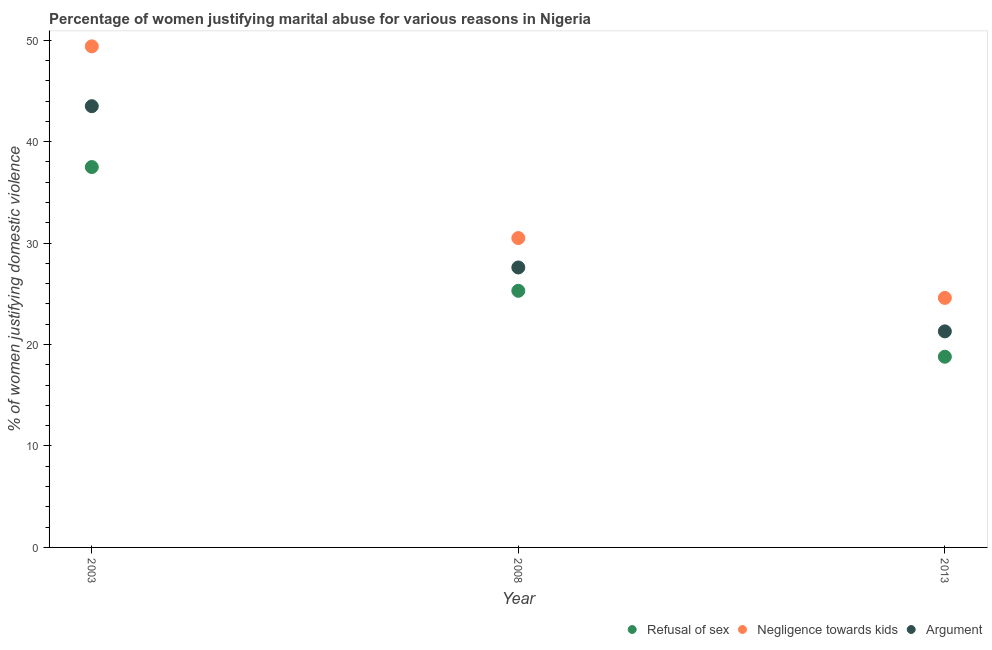What is the percentage of women justifying domestic violence due to negligence towards kids in 2008?
Your response must be concise. 30.5. Across all years, what is the maximum percentage of women justifying domestic violence due to arguments?
Provide a short and direct response. 43.5. In which year was the percentage of women justifying domestic violence due to negligence towards kids maximum?
Make the answer very short. 2003. What is the total percentage of women justifying domestic violence due to arguments in the graph?
Ensure brevity in your answer.  92.4. What is the difference between the percentage of women justifying domestic violence due to refusal of sex in 2008 and that in 2013?
Give a very brief answer. 6.5. What is the average percentage of women justifying domestic violence due to refusal of sex per year?
Provide a short and direct response. 27.2. In the year 2013, what is the difference between the percentage of women justifying domestic violence due to refusal of sex and percentage of women justifying domestic violence due to negligence towards kids?
Offer a very short reply. -5.8. What is the ratio of the percentage of women justifying domestic violence due to arguments in 2008 to that in 2013?
Offer a terse response. 1.3. What is the difference between the highest and the second highest percentage of women justifying domestic violence due to arguments?
Provide a short and direct response. 15.9. What is the difference between the highest and the lowest percentage of women justifying domestic violence due to negligence towards kids?
Make the answer very short. 24.8. In how many years, is the percentage of women justifying domestic violence due to negligence towards kids greater than the average percentage of women justifying domestic violence due to negligence towards kids taken over all years?
Make the answer very short. 1. Is it the case that in every year, the sum of the percentage of women justifying domestic violence due to refusal of sex and percentage of women justifying domestic violence due to negligence towards kids is greater than the percentage of women justifying domestic violence due to arguments?
Offer a very short reply. Yes. Does the percentage of women justifying domestic violence due to arguments monotonically increase over the years?
Offer a terse response. No. How many dotlines are there?
Offer a very short reply. 3. What is the difference between two consecutive major ticks on the Y-axis?
Give a very brief answer. 10. Are the values on the major ticks of Y-axis written in scientific E-notation?
Ensure brevity in your answer.  No. Does the graph contain any zero values?
Your response must be concise. No. What is the title of the graph?
Your answer should be very brief. Percentage of women justifying marital abuse for various reasons in Nigeria. Does "Injury" appear as one of the legend labels in the graph?
Make the answer very short. No. What is the label or title of the X-axis?
Your response must be concise. Year. What is the label or title of the Y-axis?
Keep it short and to the point. % of women justifying domestic violence. What is the % of women justifying domestic violence of Refusal of sex in 2003?
Keep it short and to the point. 37.5. What is the % of women justifying domestic violence of Negligence towards kids in 2003?
Provide a short and direct response. 49.4. What is the % of women justifying domestic violence in Argument in 2003?
Make the answer very short. 43.5. What is the % of women justifying domestic violence in Refusal of sex in 2008?
Make the answer very short. 25.3. What is the % of women justifying domestic violence in Negligence towards kids in 2008?
Give a very brief answer. 30.5. What is the % of women justifying domestic violence in Argument in 2008?
Your answer should be compact. 27.6. What is the % of women justifying domestic violence of Refusal of sex in 2013?
Offer a very short reply. 18.8. What is the % of women justifying domestic violence of Negligence towards kids in 2013?
Your answer should be very brief. 24.6. What is the % of women justifying domestic violence of Argument in 2013?
Ensure brevity in your answer.  21.3. Across all years, what is the maximum % of women justifying domestic violence in Refusal of sex?
Keep it short and to the point. 37.5. Across all years, what is the maximum % of women justifying domestic violence in Negligence towards kids?
Provide a short and direct response. 49.4. Across all years, what is the maximum % of women justifying domestic violence in Argument?
Offer a very short reply. 43.5. Across all years, what is the minimum % of women justifying domestic violence in Refusal of sex?
Provide a short and direct response. 18.8. Across all years, what is the minimum % of women justifying domestic violence of Negligence towards kids?
Your response must be concise. 24.6. Across all years, what is the minimum % of women justifying domestic violence of Argument?
Offer a terse response. 21.3. What is the total % of women justifying domestic violence of Refusal of sex in the graph?
Offer a very short reply. 81.6. What is the total % of women justifying domestic violence in Negligence towards kids in the graph?
Your answer should be very brief. 104.5. What is the total % of women justifying domestic violence in Argument in the graph?
Offer a very short reply. 92.4. What is the difference between the % of women justifying domestic violence in Refusal of sex in 2003 and that in 2008?
Provide a short and direct response. 12.2. What is the difference between the % of women justifying domestic violence in Negligence towards kids in 2003 and that in 2008?
Give a very brief answer. 18.9. What is the difference between the % of women justifying domestic violence in Negligence towards kids in 2003 and that in 2013?
Provide a short and direct response. 24.8. What is the difference between the % of women justifying domestic violence in Argument in 2003 and that in 2013?
Provide a succinct answer. 22.2. What is the difference between the % of women justifying domestic violence in Refusal of sex in 2008 and that in 2013?
Offer a terse response. 6.5. What is the difference between the % of women justifying domestic violence in Argument in 2008 and that in 2013?
Your answer should be compact. 6.3. What is the difference between the % of women justifying domestic violence of Negligence towards kids in 2003 and the % of women justifying domestic violence of Argument in 2008?
Your answer should be compact. 21.8. What is the difference between the % of women justifying domestic violence in Refusal of sex in 2003 and the % of women justifying domestic violence in Argument in 2013?
Give a very brief answer. 16.2. What is the difference between the % of women justifying domestic violence of Negligence towards kids in 2003 and the % of women justifying domestic violence of Argument in 2013?
Give a very brief answer. 28.1. What is the difference between the % of women justifying domestic violence of Refusal of sex in 2008 and the % of women justifying domestic violence of Argument in 2013?
Provide a short and direct response. 4. What is the difference between the % of women justifying domestic violence of Negligence towards kids in 2008 and the % of women justifying domestic violence of Argument in 2013?
Offer a very short reply. 9.2. What is the average % of women justifying domestic violence of Refusal of sex per year?
Give a very brief answer. 27.2. What is the average % of women justifying domestic violence of Negligence towards kids per year?
Make the answer very short. 34.83. What is the average % of women justifying domestic violence of Argument per year?
Provide a short and direct response. 30.8. In the year 2003, what is the difference between the % of women justifying domestic violence in Refusal of sex and % of women justifying domestic violence in Negligence towards kids?
Offer a terse response. -11.9. In the year 2003, what is the difference between the % of women justifying domestic violence of Refusal of sex and % of women justifying domestic violence of Argument?
Give a very brief answer. -6. In the year 2003, what is the difference between the % of women justifying domestic violence in Negligence towards kids and % of women justifying domestic violence in Argument?
Your answer should be compact. 5.9. In the year 2008, what is the difference between the % of women justifying domestic violence of Refusal of sex and % of women justifying domestic violence of Argument?
Your answer should be compact. -2.3. In the year 2013, what is the difference between the % of women justifying domestic violence of Refusal of sex and % of women justifying domestic violence of Argument?
Your answer should be compact. -2.5. What is the ratio of the % of women justifying domestic violence in Refusal of sex in 2003 to that in 2008?
Provide a short and direct response. 1.48. What is the ratio of the % of women justifying domestic violence in Negligence towards kids in 2003 to that in 2008?
Give a very brief answer. 1.62. What is the ratio of the % of women justifying domestic violence of Argument in 2003 to that in 2008?
Keep it short and to the point. 1.58. What is the ratio of the % of women justifying domestic violence of Refusal of sex in 2003 to that in 2013?
Your response must be concise. 1.99. What is the ratio of the % of women justifying domestic violence in Negligence towards kids in 2003 to that in 2013?
Your response must be concise. 2.01. What is the ratio of the % of women justifying domestic violence in Argument in 2003 to that in 2013?
Provide a short and direct response. 2.04. What is the ratio of the % of women justifying domestic violence of Refusal of sex in 2008 to that in 2013?
Give a very brief answer. 1.35. What is the ratio of the % of women justifying domestic violence of Negligence towards kids in 2008 to that in 2013?
Ensure brevity in your answer.  1.24. What is the ratio of the % of women justifying domestic violence in Argument in 2008 to that in 2013?
Offer a very short reply. 1.3. What is the difference between the highest and the second highest % of women justifying domestic violence of Refusal of sex?
Your answer should be very brief. 12.2. What is the difference between the highest and the second highest % of women justifying domestic violence in Argument?
Your answer should be compact. 15.9. What is the difference between the highest and the lowest % of women justifying domestic violence in Negligence towards kids?
Provide a short and direct response. 24.8. What is the difference between the highest and the lowest % of women justifying domestic violence of Argument?
Give a very brief answer. 22.2. 